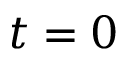<formula> <loc_0><loc_0><loc_500><loc_500>t = 0</formula> 